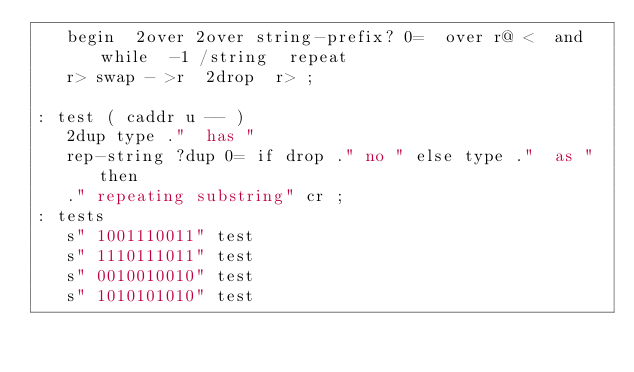Convert code to text. <code><loc_0><loc_0><loc_500><loc_500><_Forth_>   begin  2over 2over string-prefix? 0=  over r@ <  and  while  -1 /string  repeat
   r> swap - >r  2drop  r> ;

: test ( caddr u -- )
   2dup type ."  has "
   rep-string ?dup 0= if drop ." no " else type ."  as " then
   ." repeating substring" cr ;
: tests
   s" 1001110011" test
   s" 1110111011" test
   s" 0010010010" test
   s" 1010101010" test</code> 